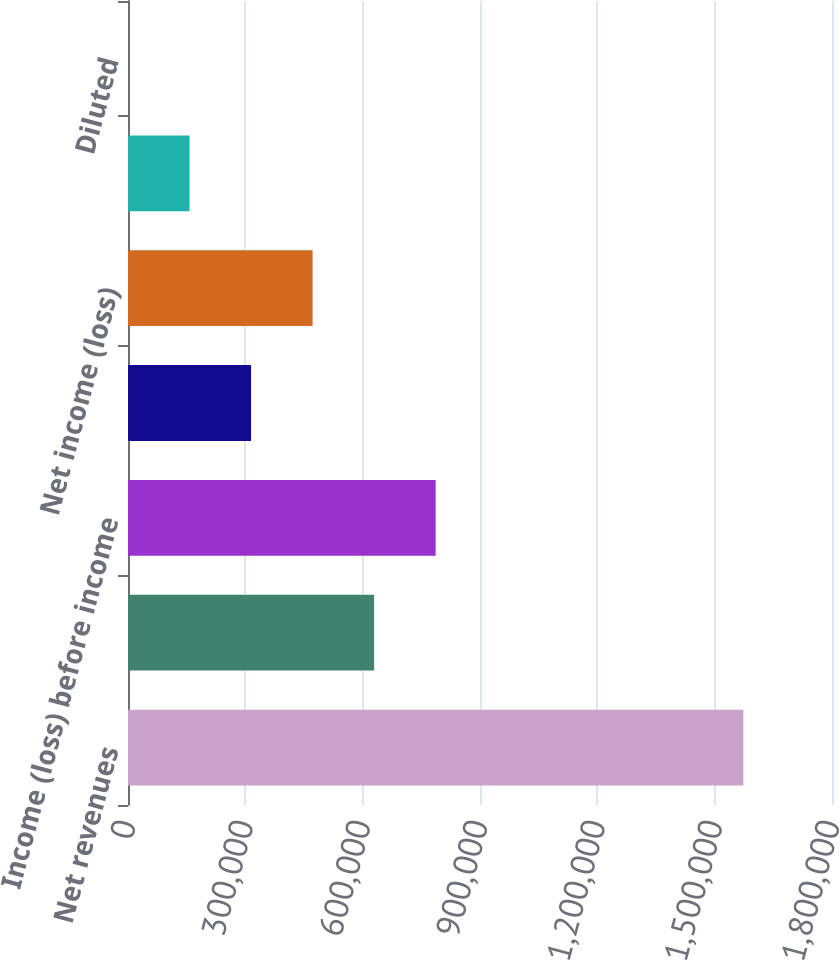Convert chart to OTSL. <chart><loc_0><loc_0><loc_500><loc_500><bar_chart><fcel>Net revenues<fcel>Operating income (loss)<fcel>Income (loss) before income<fcel>Provision (benefit) for income<fcel>Net income (loss)<fcel>Basic<fcel>Diluted<nl><fcel>1.57323e+06<fcel>629294<fcel>786617<fcel>314647<fcel>471970<fcel>157324<fcel>0.87<nl></chart> 